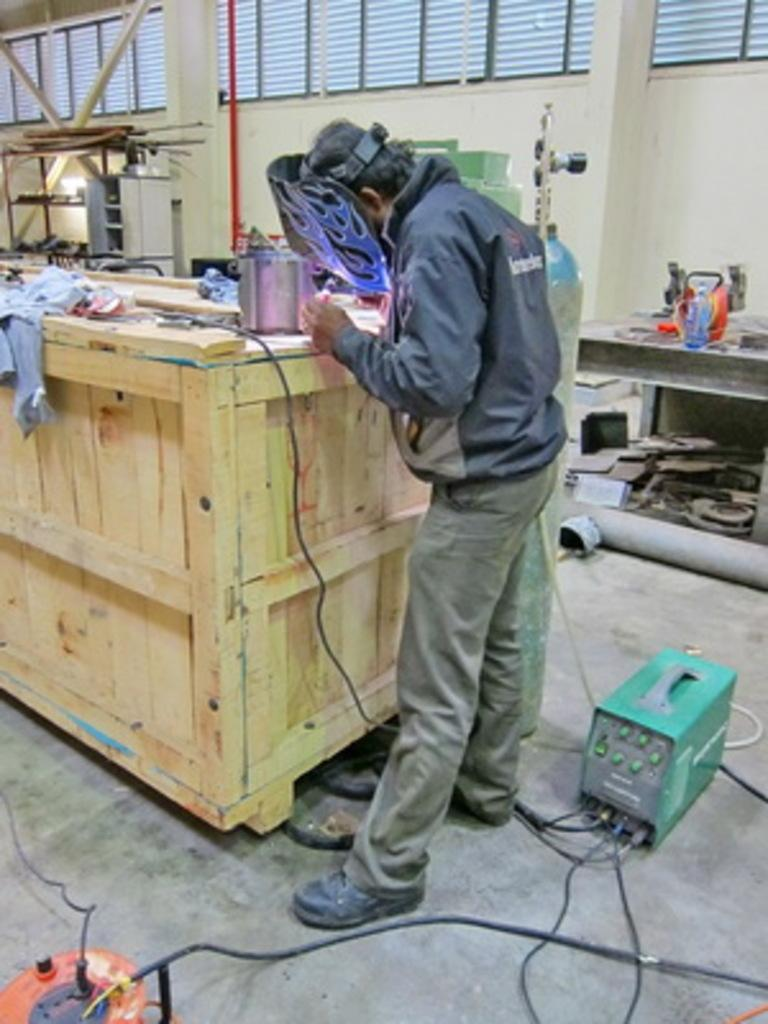Who is the main subject in the image? There is a man in the image. Where is the man positioned in the image? The man is standing in the front. What is the man wearing in the image? The man is wearing a mask. What is the man doing in the image? The man is working on a wooden table. What can be seen in the background of the image? There is a white wall in the background, and window glasses are on the top of the wall. Are there any chickens present in the image? No, there are no chickens present in the image. How does the man plan to join his friend in the image? There is no mention of a friend in the image, so it is not possible to determine how the man plans to join them. 